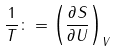<formula> <loc_0><loc_0><loc_500><loc_500>\frac { 1 } { T } \colon = \left ( \frac { \partial S } { \partial U } \right ) _ { V }</formula> 